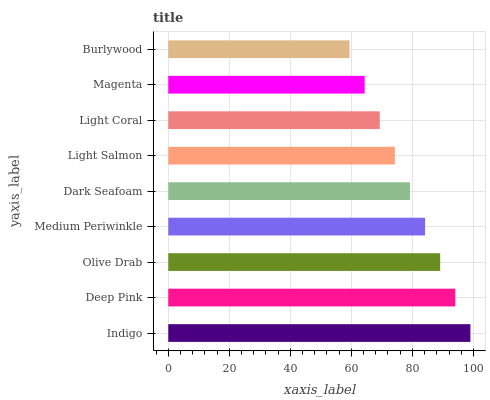Is Burlywood the minimum?
Answer yes or no. Yes. Is Indigo the maximum?
Answer yes or no. Yes. Is Deep Pink the minimum?
Answer yes or no. No. Is Deep Pink the maximum?
Answer yes or no. No. Is Indigo greater than Deep Pink?
Answer yes or no. Yes. Is Deep Pink less than Indigo?
Answer yes or no. Yes. Is Deep Pink greater than Indigo?
Answer yes or no. No. Is Indigo less than Deep Pink?
Answer yes or no. No. Is Dark Seafoam the high median?
Answer yes or no. Yes. Is Dark Seafoam the low median?
Answer yes or no. Yes. Is Light Coral the high median?
Answer yes or no. No. Is Medium Periwinkle the low median?
Answer yes or no. No. 